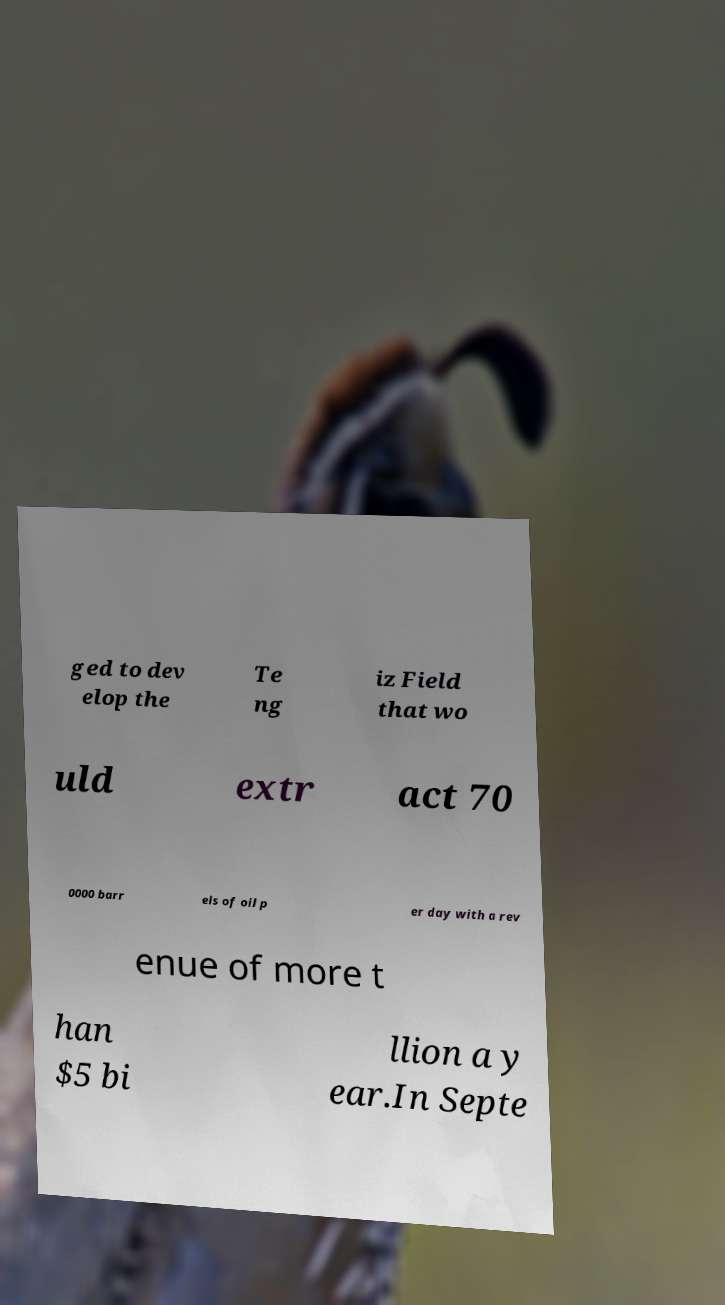Could you assist in decoding the text presented in this image and type it out clearly? ged to dev elop the Te ng iz Field that wo uld extr act 70 0000 barr els of oil p er day with a rev enue of more t han $5 bi llion a y ear.In Septe 